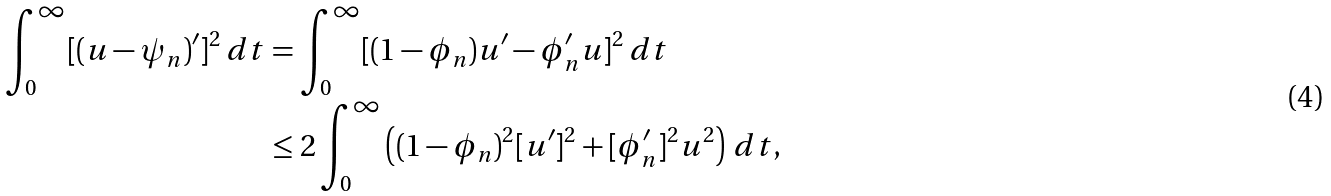<formula> <loc_0><loc_0><loc_500><loc_500>\int _ { 0 } ^ { \infty } [ ( u - \psi _ { n } ) ^ { \prime } ] ^ { 2 } \, d t & = \int _ { 0 } ^ { \infty } [ ( 1 - \phi _ { n } ) u ^ { \prime } - \phi _ { n } ^ { \prime } u ] ^ { 2 } \, d t \\ & \leq 2 \int _ { 0 } ^ { \infty } \left ( ( 1 - \phi _ { n } ) ^ { 2 } [ u ^ { \prime } ] ^ { 2 } + [ \phi _ { n } ^ { \prime } ] ^ { 2 } u ^ { 2 } \right ) \, d t ,</formula> 